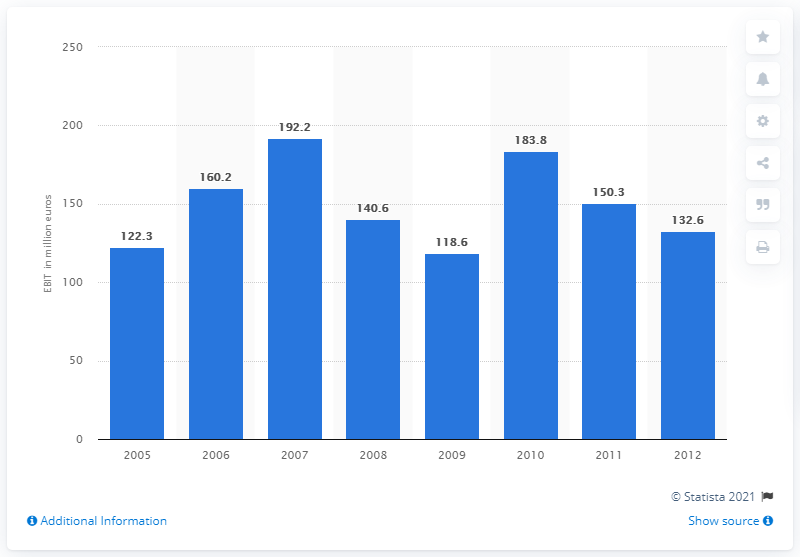Mention a couple of crucial points in this snapshot. In 2010, Indesit's earnings before interest and taxes (EBIT) was 183.8. 